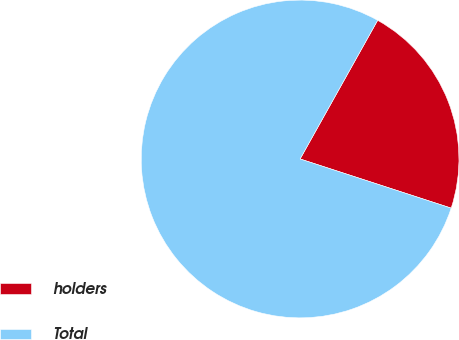Convert chart to OTSL. <chart><loc_0><loc_0><loc_500><loc_500><pie_chart><fcel>holders<fcel>Total<nl><fcel>21.89%<fcel>78.11%<nl></chart> 